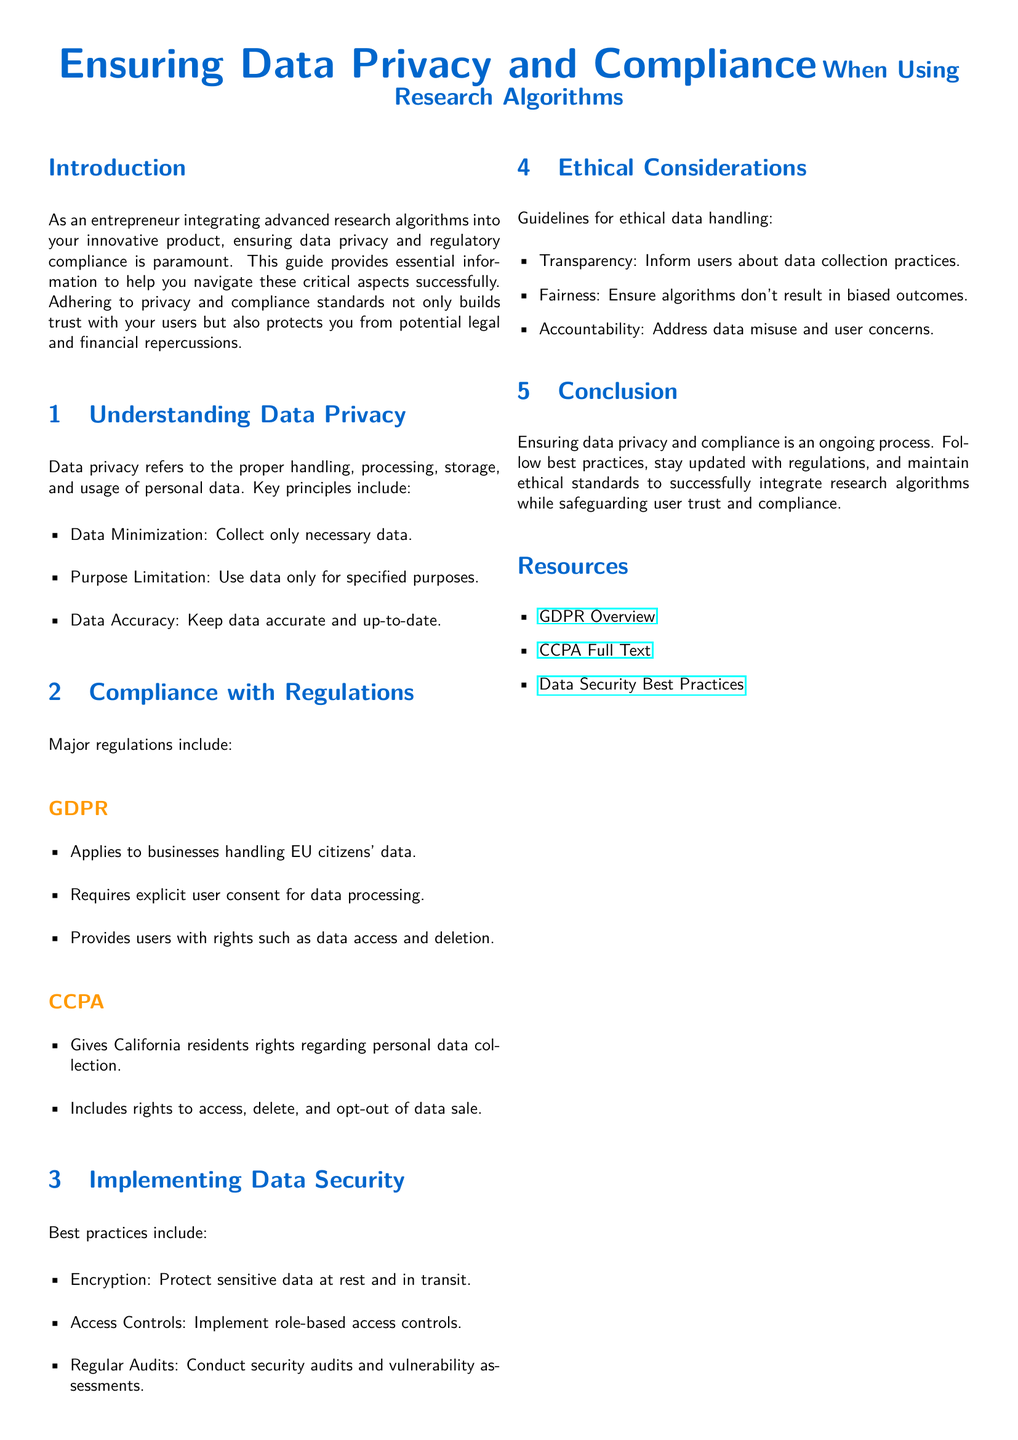What is the title of the document? The title is clearly stated at the beginning of the document and reflects the content focus.
Answer: Ensuring Data Privacy and Compliance When Using Research Algorithms What does data minimization refer to? This concept is mentioned under the key principles of data privacy, emphasizing the importance of collecting only necessary data.
Answer: Collect only necessary data Which regulation applies to businesses handling EU citizens' data? This regulation is specifically listed in the compliance section of the document, focusing on data protection for EU residents.
Answer: GDPR What is one of the ethical considerations mentioned? The ethical considerations section lists various guidelines, with this aspect promoting fair practices regarding user data.
Answer: Transparency What is a suggested best practice for implementing data security? This practice is one of several listed under data security, highlighting methods to protect sensitive information.
Answer: Encryption 